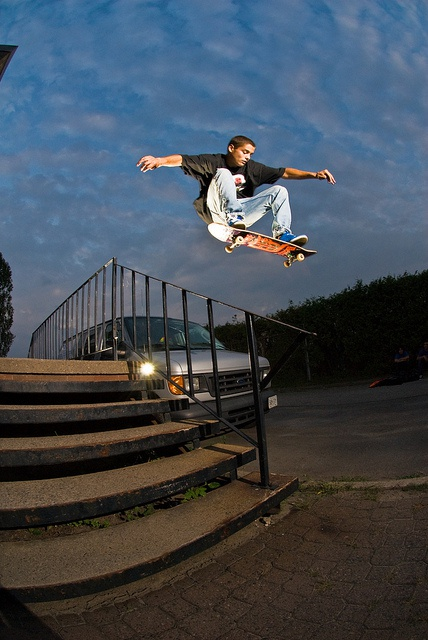Describe the objects in this image and their specific colors. I can see truck in blue, black, gray, and darkgray tones, people in blue, black, lightgray, gray, and darkgray tones, skateboard in blue, white, black, tan, and gray tones, people in black and blue tones, and people in black and blue tones in this image. 